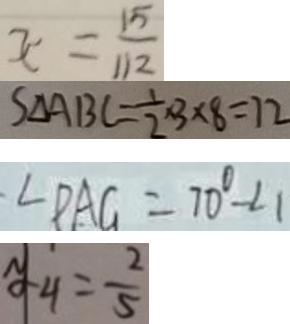Convert formula to latex. <formula><loc_0><loc_0><loc_500><loc_500>x = \frac { 1 5 } { 1 1 2 } 
 S _ { \Delta } A B C = \frac { 1 } { 2 } \times 3 \times 8 = 7 2 
 \angle D A G = 7 0 ^ { \circ } - \angle 1 
 y _ { 4 } = \frac { 2 } { 5 }</formula> 